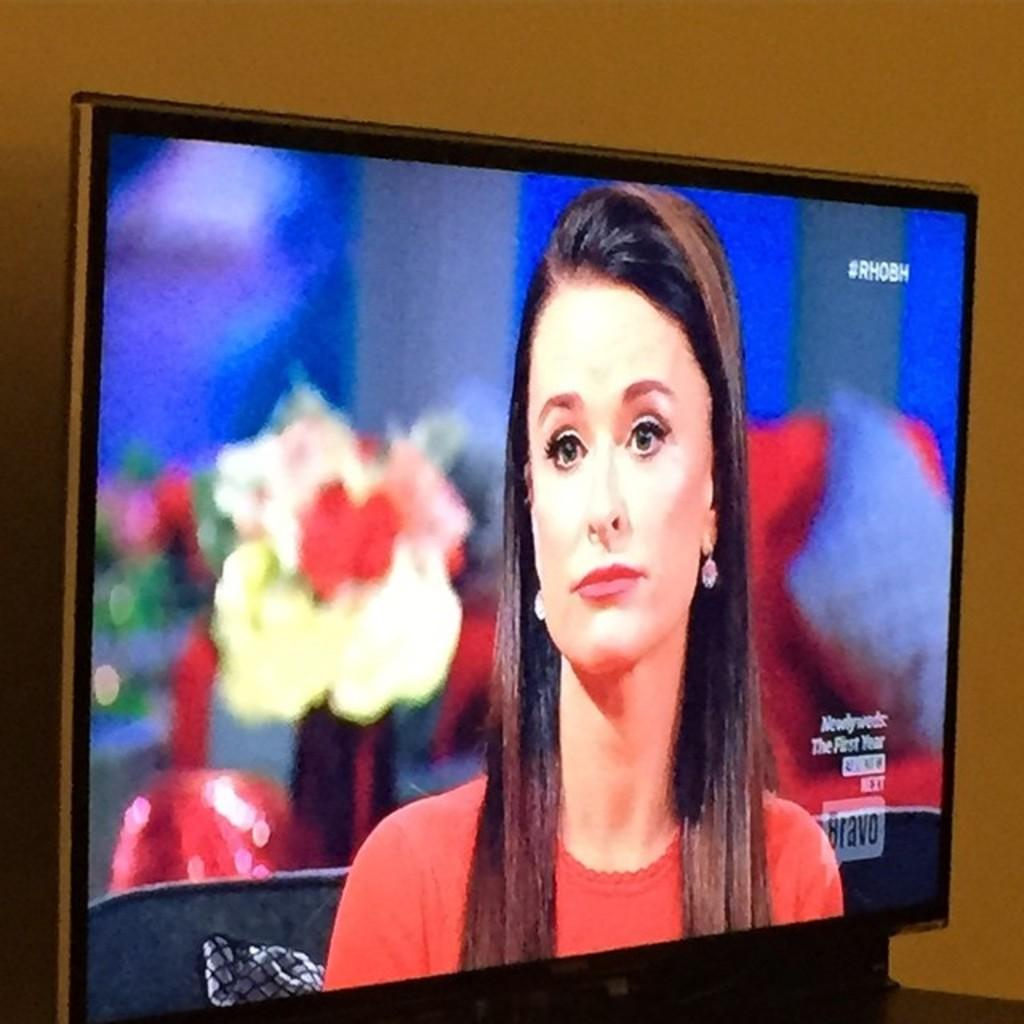What electronic device is present in the image? There is a television in the image. How is the television positioned in the room? The television is attached to the wall. What feature of the television is visible in the image? The television has a display screen. What is being shown on the television screen? There is a picture of a woman sitting on the screen. How many dogs are sitting on the flag in the image? There is no flag or dogs present in the image. 